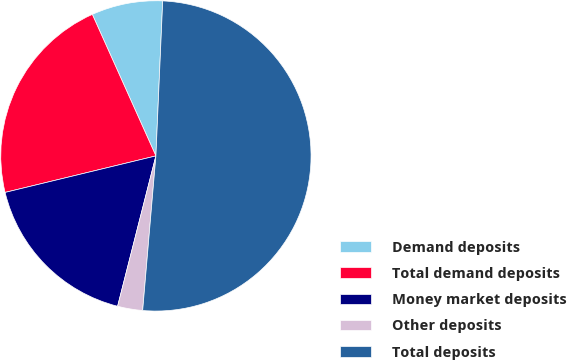Convert chart. <chart><loc_0><loc_0><loc_500><loc_500><pie_chart><fcel>Demand deposits<fcel>Total demand deposits<fcel>Money market deposits<fcel>Other deposits<fcel>Total deposits<nl><fcel>7.42%<fcel>22.06%<fcel>17.25%<fcel>2.61%<fcel>50.66%<nl></chart> 